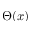<formula> <loc_0><loc_0><loc_500><loc_500>\Theta ( x )</formula> 